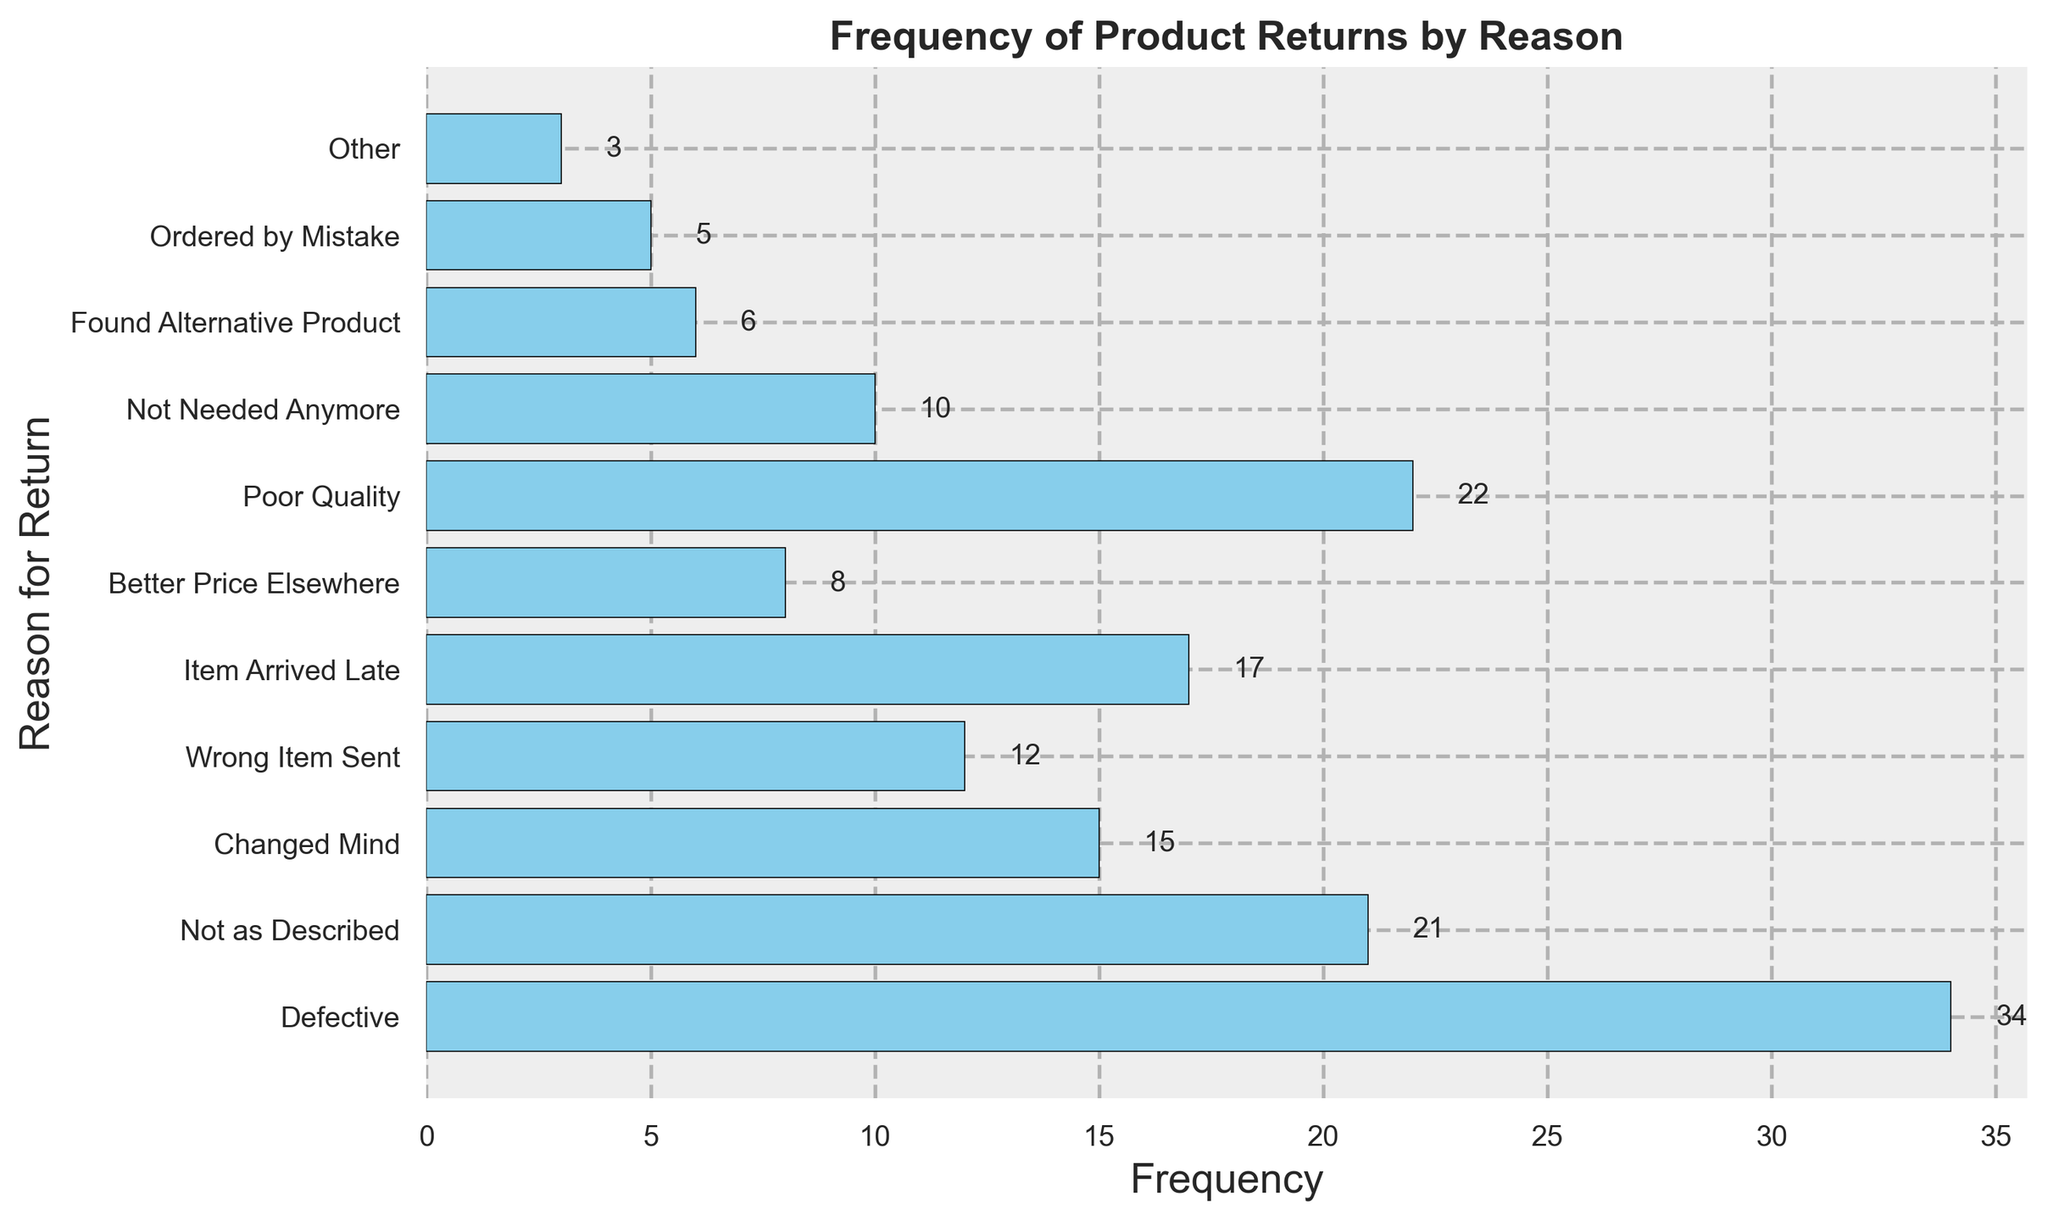Which reason led to the most product returns? The bar corresponding to 'Defective' is the longest, indicating the highest frequency of returns.
Answer: Defective What is the total number of returns for 'Not as Described' and 'Wrong Item Sent'? The frequency of 'Not as Described' is 21, and the frequency of 'Wrong Item Sent' is 12. Adding them together gives 21 + 12.
Answer: 33 Which two reasons have the closest frequencies of returns? 'Not as Described' has a frequency of 21, and 'Poor Quality' has a frequency of 22, which are very close.
Answer: Not as Described and Poor Quality What is the difference in the number of returns between 'Defective' and 'Poor Quality'? The frequency of 'Defective' is 34, and the frequency of 'Poor Quality' is 22. The difference is 34 - 22.
Answer: 12 How many returns were due to 'Ordered by Mistake' combined with 'Found Alternative Product'? The frequency of 'Ordered by Mistake' is 5, and the frequency of 'Found Alternative Product' is 6. Adding them together results in 5 + 6.
Answer: 11 What is the combined frequency of returns for all reasons starting with 'N'? Summing the frequencies: 'Not as Described' (21), 'Not Needed Anymore' (10) gives 21 + 10.
Answer: 31 Which category has more returns: 'Item Arrived Late' or 'Changed Mind'? The frequency for 'Item Arrived Late' is higher than for 'Changed Mind' (17 vs. 15).
Answer: Item Arrived Late What is the combined total of returns for 'Changed Mind', 'Wrong Item Sent', and 'Better Price Elsewhere'? Add the frequencies: 'Changed Mind' (15), 'Wrong Item Sent' (12), and 'Better Price Elsewhere' (8) results in 15 + 12 + 8.
Answer: 35 By how much does the 'Poor Quality' frequency exceed the 'Item Arrived Late' frequency? The frequency of 'Poor Quality' is 22, and the frequency of 'Item Arrived Late' is 17. The difference is 22 - 17.
Answer: 5 